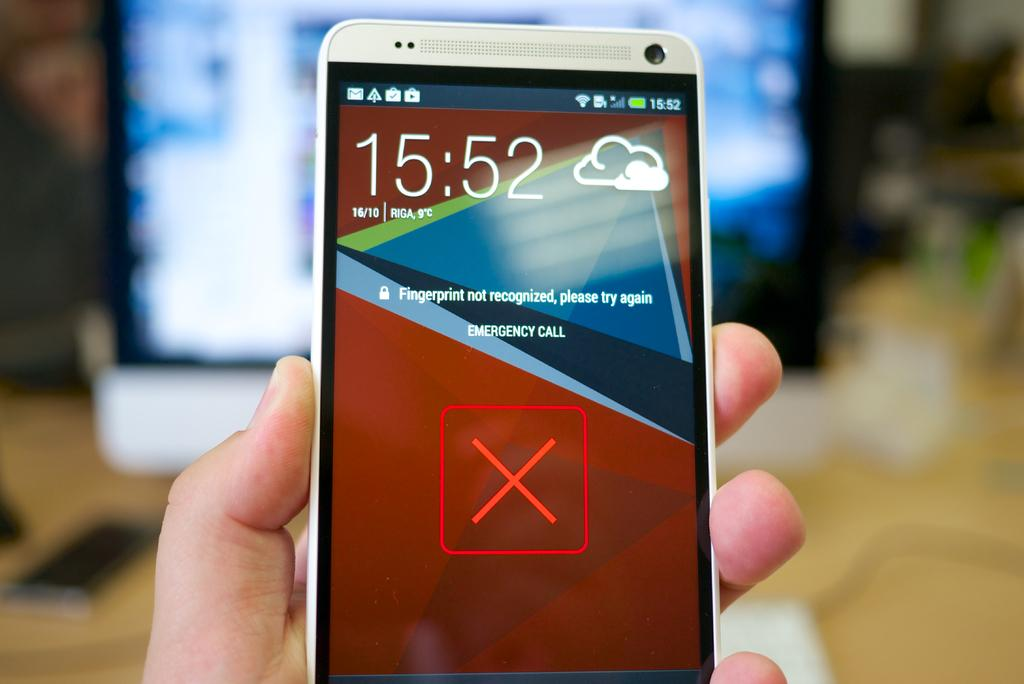<image>
Write a terse but informative summary of the picture. A cell phone informs the user the finger print was not recognized 